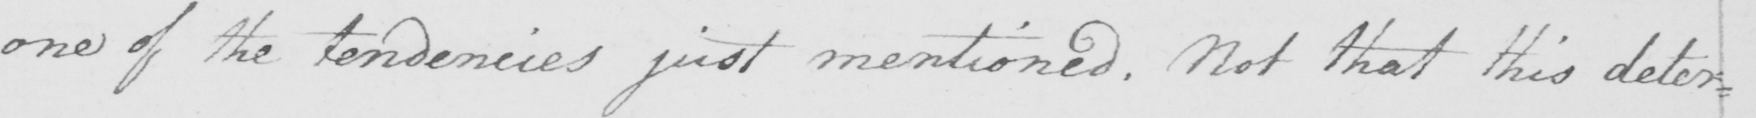What text is written in this handwritten line? one of the tendencies just mentioned. Not that this deter= 